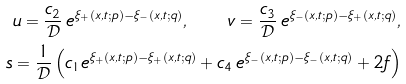<formula> <loc_0><loc_0><loc_500><loc_500>u = \frac { c _ { 2 } } { \mathcal { D } } \, e ^ { \xi _ { + } ( x , t ; p ) - \xi _ { - } ( x , t ; q ) } , \quad v = \frac { c _ { 3 } } { \mathcal { D } } \, e ^ { \xi _ { - } ( x , t ; p ) - \xi _ { + } ( x , t ; q ) } , \\ s = \frac { 1 } { \mathcal { D } } \left ( c _ { 1 } e ^ { \xi _ { + } ( x , t ; p ) - \xi _ { + } ( x , t ; q ) } + c _ { 4 } \, e ^ { \xi _ { - } ( x , t ; p ) - \xi _ { - } ( x , t ; q ) } + 2 f \right )</formula> 